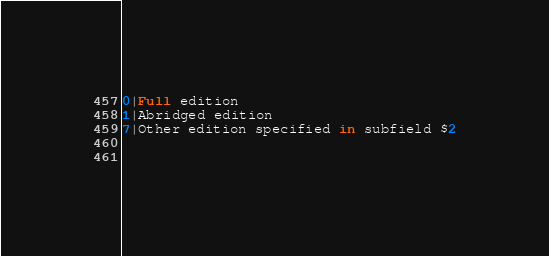<code> <loc_0><loc_0><loc_500><loc_500><_SQL_>0|Full edition
1|Abridged edition
7|Other edition specified in subfield $2

 </code> 